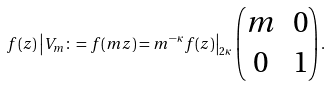<formula> <loc_0><loc_0><loc_500><loc_500>f ( z ) \left | V _ { m } \colon = f ( m z ) = m ^ { - \kappa } f ( z ) \right | _ { 2 \kappa } \begin{pmatrix} m & 0 \\ 0 & 1 \end{pmatrix} .</formula> 